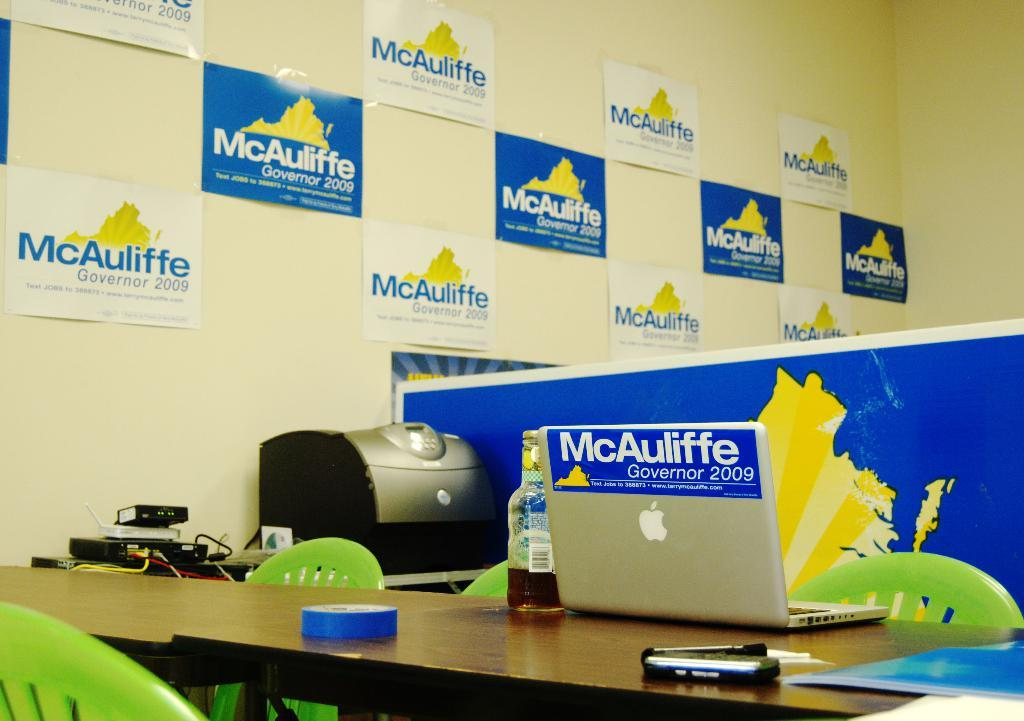<image>
Render a clear and concise summary of the photo. Political posters for a man named McAuliffe who was standing as a Governor. 